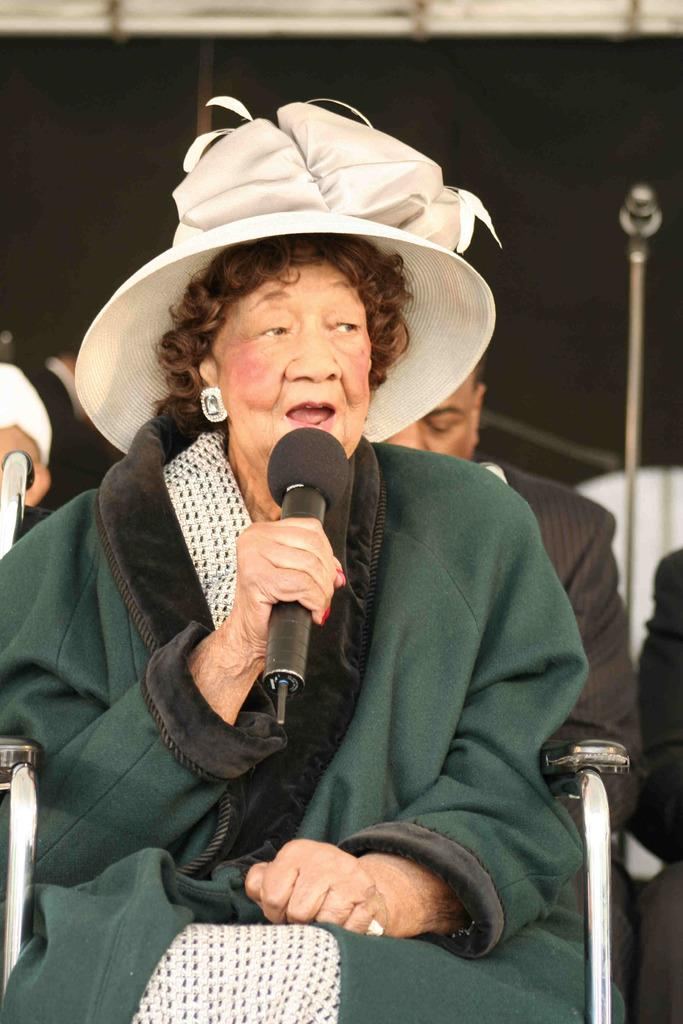Who is the main subject in the image? There is a woman in the image. What is the woman doing in the image? The woman is sitting on a chair and singing on a microphone. Can you describe the setting of the image? There is a person sitting in the background of the image. What type of wind instruments can be seen in the image? There are no wind instruments present in the image. What kind of sticks are used to play the music in the image? There is no indication of any instruments being played with sticks in the image. 